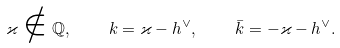Convert formula to latex. <formula><loc_0><loc_0><loc_500><loc_500>\varkappa \notin \mathbb { Q } , \quad k = \varkappa - h ^ { \vee } , \quad \bar { k } = - \varkappa - h ^ { \vee } .</formula> 